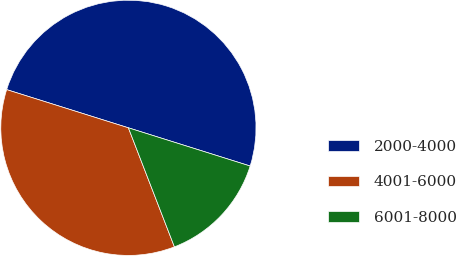Convert chart. <chart><loc_0><loc_0><loc_500><loc_500><pie_chart><fcel>2000-4000<fcel>4001-6000<fcel>6001-8000<nl><fcel>50.0%<fcel>35.71%<fcel>14.29%<nl></chart> 